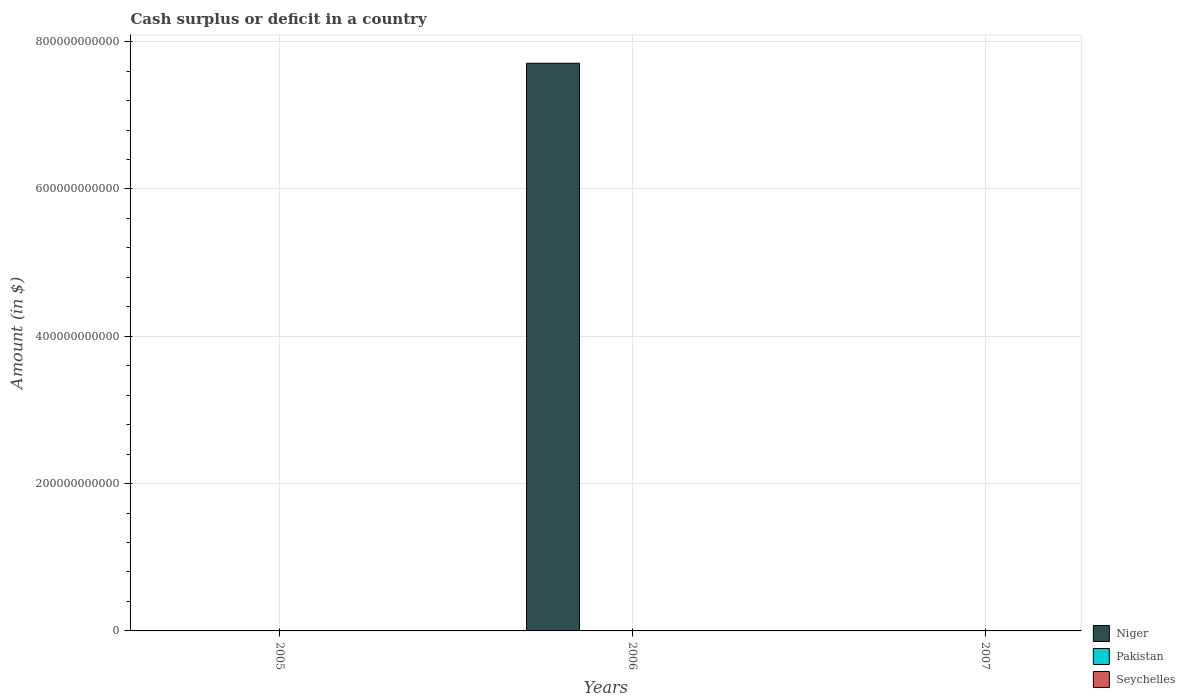How many bars are there on the 2nd tick from the right?
Provide a succinct answer. 2. What is the label of the 2nd group of bars from the left?
Provide a succinct answer. 2006. In how many cases, is the number of bars for a given year not equal to the number of legend labels?
Make the answer very short. 3. What is the amount of cash surplus or deficit in Niger in 2005?
Give a very brief answer. 0. Across all years, what is the maximum amount of cash surplus or deficit in Niger?
Offer a very short reply. 7.71e+11. Across all years, what is the minimum amount of cash surplus or deficit in Seychelles?
Your response must be concise. 0. What is the total amount of cash surplus or deficit in Niger in the graph?
Provide a short and direct response. 7.71e+11. What is the difference between the amount of cash surplus or deficit in Seychelles in 2005 and that in 2006?
Offer a very short reply. 1.55e+06. What is the difference between the amount of cash surplus or deficit in Niger in 2005 and the amount of cash surplus or deficit in Pakistan in 2006?
Provide a short and direct response. 0. What is the average amount of cash surplus or deficit in Seychelles per year?
Keep it short and to the point. 8.17e+07. In the year 2006, what is the difference between the amount of cash surplus or deficit in Niger and amount of cash surplus or deficit in Seychelles?
Offer a terse response. 7.71e+11. In how many years, is the amount of cash surplus or deficit in Niger greater than 360000000000 $?
Provide a short and direct response. 1. Is the amount of cash surplus or deficit in Seychelles in 2005 less than that in 2006?
Your answer should be compact. No. What is the difference between the highest and the lowest amount of cash surplus or deficit in Seychelles?
Keep it short and to the point. 1.23e+08. In how many years, is the amount of cash surplus or deficit in Niger greater than the average amount of cash surplus or deficit in Niger taken over all years?
Offer a very short reply. 1. Is it the case that in every year, the sum of the amount of cash surplus or deficit in Pakistan and amount of cash surplus or deficit in Niger is greater than the amount of cash surplus or deficit in Seychelles?
Offer a very short reply. No. Are all the bars in the graph horizontal?
Your answer should be very brief. No. How many years are there in the graph?
Your response must be concise. 3. What is the difference between two consecutive major ticks on the Y-axis?
Offer a terse response. 2.00e+11. Are the values on the major ticks of Y-axis written in scientific E-notation?
Your answer should be compact. No. Does the graph contain grids?
Keep it short and to the point. Yes. How many legend labels are there?
Your response must be concise. 3. How are the legend labels stacked?
Offer a very short reply. Vertical. What is the title of the graph?
Ensure brevity in your answer.  Cash surplus or deficit in a country. What is the label or title of the X-axis?
Offer a terse response. Years. What is the label or title of the Y-axis?
Provide a short and direct response. Amount (in $). What is the Amount (in $) of Niger in 2005?
Offer a very short reply. 0. What is the Amount (in $) of Seychelles in 2005?
Offer a terse response. 1.23e+08. What is the Amount (in $) in Niger in 2006?
Offer a terse response. 7.71e+11. What is the Amount (in $) of Seychelles in 2006?
Provide a succinct answer. 1.22e+08. What is the Amount (in $) of Niger in 2007?
Provide a short and direct response. 0. What is the Amount (in $) in Pakistan in 2007?
Keep it short and to the point. 0. Across all years, what is the maximum Amount (in $) in Niger?
Your answer should be compact. 7.71e+11. Across all years, what is the maximum Amount (in $) in Seychelles?
Provide a short and direct response. 1.23e+08. Across all years, what is the minimum Amount (in $) of Seychelles?
Ensure brevity in your answer.  0. What is the total Amount (in $) in Niger in the graph?
Keep it short and to the point. 7.71e+11. What is the total Amount (in $) in Pakistan in the graph?
Offer a terse response. 0. What is the total Amount (in $) of Seychelles in the graph?
Your answer should be very brief. 2.45e+08. What is the difference between the Amount (in $) of Seychelles in 2005 and that in 2006?
Ensure brevity in your answer.  1.55e+06. What is the average Amount (in $) in Niger per year?
Give a very brief answer. 2.57e+11. What is the average Amount (in $) of Pakistan per year?
Make the answer very short. 0. What is the average Amount (in $) of Seychelles per year?
Provide a short and direct response. 8.17e+07. In the year 2006, what is the difference between the Amount (in $) of Niger and Amount (in $) of Seychelles?
Give a very brief answer. 7.71e+11. What is the ratio of the Amount (in $) in Seychelles in 2005 to that in 2006?
Provide a short and direct response. 1.01. What is the difference between the highest and the lowest Amount (in $) of Niger?
Keep it short and to the point. 7.71e+11. What is the difference between the highest and the lowest Amount (in $) of Seychelles?
Provide a short and direct response. 1.23e+08. 